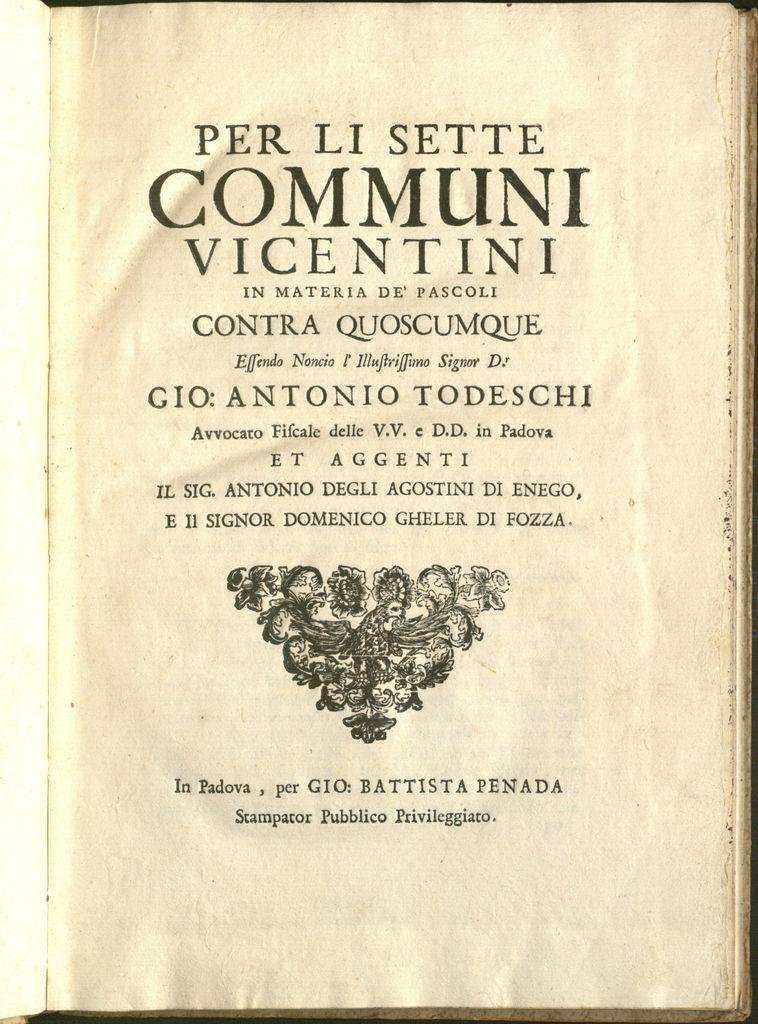Provide a one-sentence caption for the provided image. A book title with graphics is written in a foreign language. 